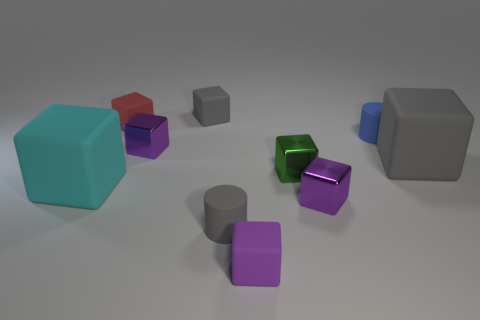What size is the cyan object that is the same shape as the small red matte object?
Give a very brief answer. Large. There is a purple block that is made of the same material as the small blue thing; what size is it?
Ensure brevity in your answer.  Small. What is the color of the other big thing that is the same material as the large cyan thing?
Keep it short and to the point. Gray. Are there any yellow rubber blocks of the same size as the cyan matte cube?
Keep it short and to the point. No. There is a tiny green object that is the same shape as the red object; what is it made of?
Keep it short and to the point. Metal. There is a blue thing that is the same size as the green metal thing; what is its shape?
Offer a terse response. Cylinder. Are there any other small rubber objects that have the same shape as the blue object?
Provide a succinct answer. Yes. The small blue object that is behind the matte cylinder in front of the tiny blue matte cylinder is what shape?
Your response must be concise. Cylinder. The big cyan thing is what shape?
Ensure brevity in your answer.  Cube. What is the material of the cylinder behind the large rubber thing in front of the small green object in front of the tiny blue object?
Your response must be concise. Rubber. 